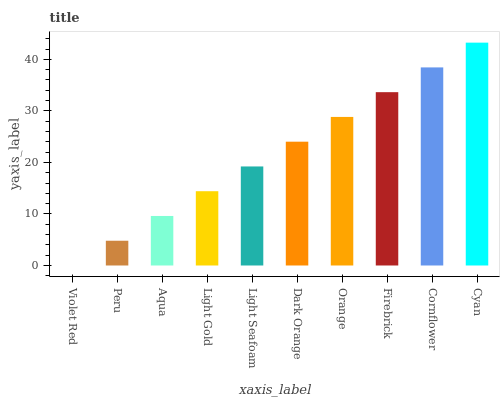Is Violet Red the minimum?
Answer yes or no. Yes. Is Cyan the maximum?
Answer yes or no. Yes. Is Peru the minimum?
Answer yes or no. No. Is Peru the maximum?
Answer yes or no. No. Is Peru greater than Violet Red?
Answer yes or no. Yes. Is Violet Red less than Peru?
Answer yes or no. Yes. Is Violet Red greater than Peru?
Answer yes or no. No. Is Peru less than Violet Red?
Answer yes or no. No. Is Dark Orange the high median?
Answer yes or no. Yes. Is Light Seafoam the low median?
Answer yes or no. Yes. Is Light Gold the high median?
Answer yes or no. No. Is Dark Orange the low median?
Answer yes or no. No. 